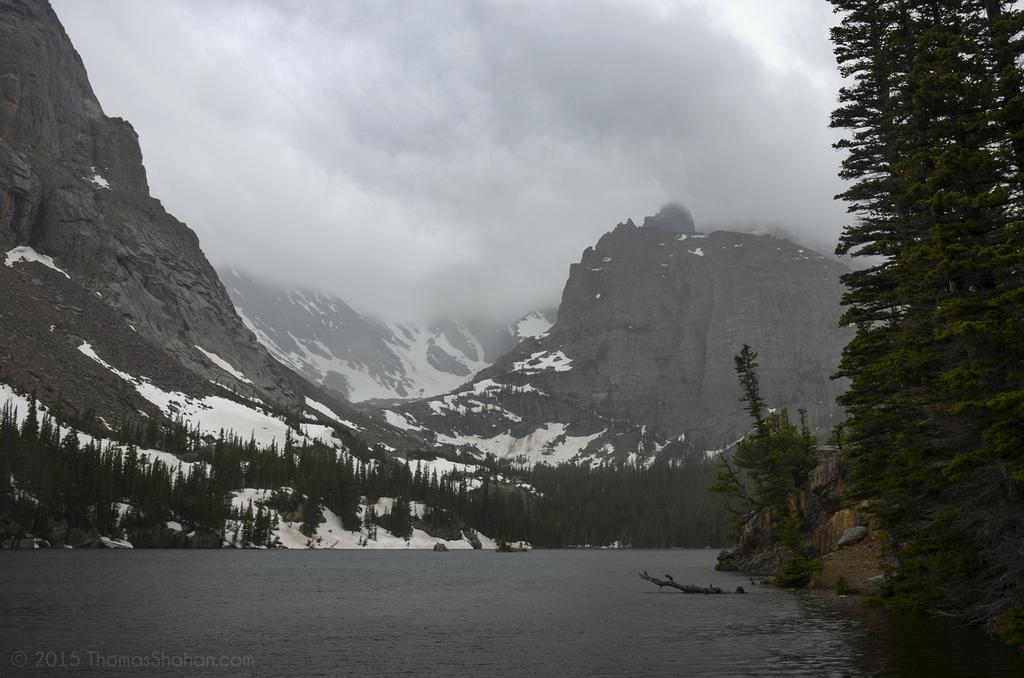What is the primary element visible in the image? There is water in the image. What type of vegetation can be seen in the image? There are trees in the image. What geographical feature is visible in the background of the image? There are mountains in the background of the image. What is the condition of the mountains in the image? There is snow on the mountains. Are there any trees on the mountains in the image? Yes, there are trees on the mountains. What part of the natural environment is visible in the image? The sky is visible in the image. What type of pizzas are being served on the desk in the image? There is no desk or pizzas present in the image; it features water, trees, mountains, and a sky. What month is depicted in the image? The image does not depict a specific month; it only shows water, trees, mountains, and a sky. 